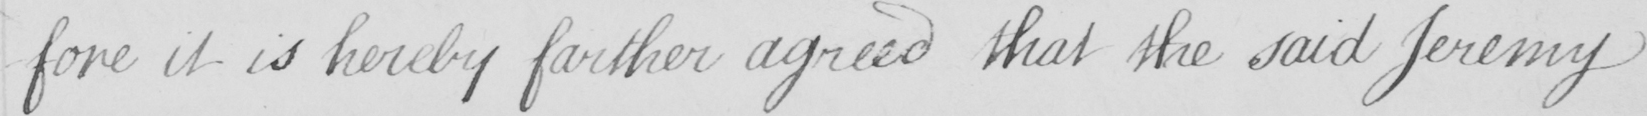What does this handwritten line say? -fore it is hereby farther agreed that the said Jeremy 